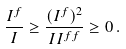Convert formula to latex. <formula><loc_0><loc_0><loc_500><loc_500>\frac { I ^ { f } } { I } \geq \frac { ( I ^ { f } ) ^ { 2 } } { I I ^ { f f } } \geq 0 \, .</formula> 